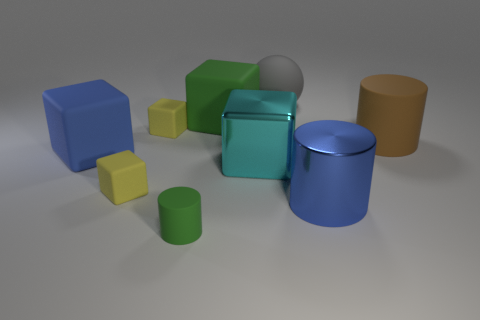Add 1 big rubber objects. How many objects exist? 10 Subtract all big cylinders. How many cylinders are left? 1 Subtract all blue blocks. How many blocks are left? 4 Subtract all blocks. How many objects are left? 4 Subtract all red blocks. How many red balls are left? 0 Subtract all large green objects. Subtract all tiny yellow metal cubes. How many objects are left? 8 Add 7 metal cubes. How many metal cubes are left? 8 Add 4 big matte spheres. How many big matte spheres exist? 5 Subtract 2 yellow cubes. How many objects are left? 7 Subtract 3 cylinders. How many cylinders are left? 0 